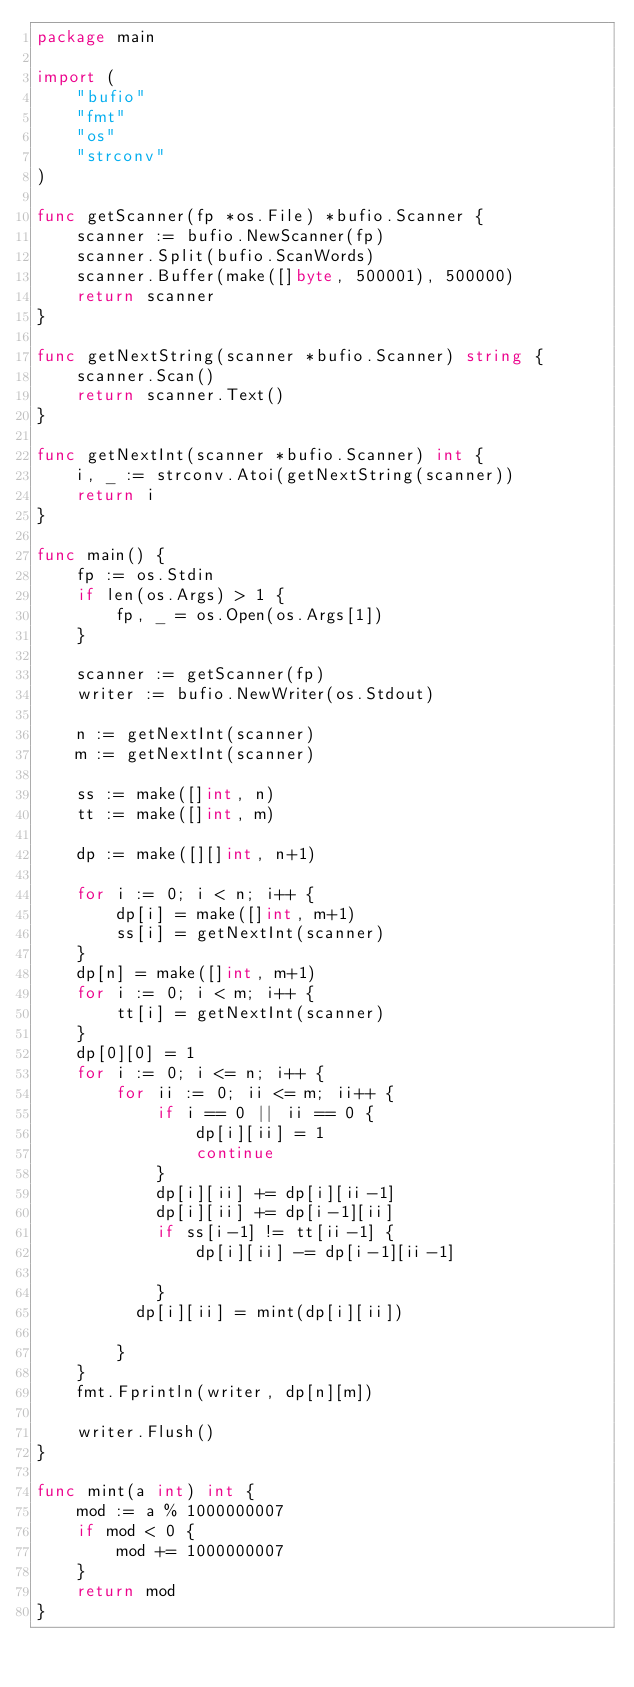<code> <loc_0><loc_0><loc_500><loc_500><_Go_>package main

import (
	"bufio"
	"fmt"
	"os"
	"strconv"
)

func getScanner(fp *os.File) *bufio.Scanner {
	scanner := bufio.NewScanner(fp)
	scanner.Split(bufio.ScanWords)
	scanner.Buffer(make([]byte, 500001), 500000)
	return scanner
}

func getNextString(scanner *bufio.Scanner) string {
	scanner.Scan()
	return scanner.Text()
}

func getNextInt(scanner *bufio.Scanner) int {
	i, _ := strconv.Atoi(getNextString(scanner))
	return i
}

func main() {
	fp := os.Stdin
	if len(os.Args) > 1 {
		fp, _ = os.Open(os.Args[1])
	}

	scanner := getScanner(fp)
	writer := bufio.NewWriter(os.Stdout)

	n := getNextInt(scanner)
	m := getNextInt(scanner)

	ss := make([]int, n)
	tt := make([]int, m)

	dp := make([][]int, n+1)

	for i := 0; i < n; i++ {
		dp[i] = make([]int, m+1)
		ss[i] = getNextInt(scanner)
	}
	dp[n] = make([]int, m+1)
	for i := 0; i < m; i++ {
		tt[i] = getNextInt(scanner)
	}
	dp[0][0] = 1
	for i := 0; i <= n; i++ {
		for ii := 0; ii <= m; ii++ {
			if i == 0 || ii == 0 {
				dp[i][ii] = 1
				continue
			}
			dp[i][ii] += dp[i][ii-1]
			dp[i][ii] += dp[i-1][ii]
			if ss[i-1] != tt[ii-1] {
				dp[i][ii] -= dp[i-1][ii-1]
				
			}
          dp[i][ii] = mint(dp[i][ii])

		}
	}
	fmt.Fprintln(writer, dp[n][m])

	writer.Flush()
}

func mint(a int) int {
	mod := a % 1000000007
	if mod < 0 {
		mod += 1000000007
	}
	return mod
}
</code> 